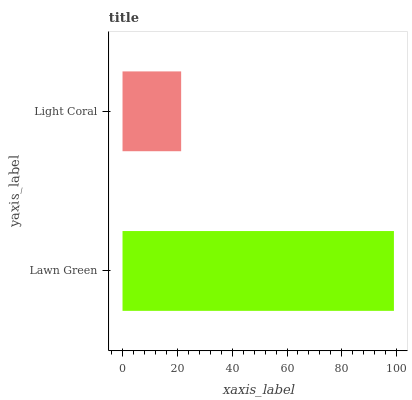Is Light Coral the minimum?
Answer yes or no. Yes. Is Lawn Green the maximum?
Answer yes or no. Yes. Is Light Coral the maximum?
Answer yes or no. No. Is Lawn Green greater than Light Coral?
Answer yes or no. Yes. Is Light Coral less than Lawn Green?
Answer yes or no. Yes. Is Light Coral greater than Lawn Green?
Answer yes or no. No. Is Lawn Green less than Light Coral?
Answer yes or no. No. Is Lawn Green the high median?
Answer yes or no. Yes. Is Light Coral the low median?
Answer yes or no. Yes. Is Light Coral the high median?
Answer yes or no. No. Is Lawn Green the low median?
Answer yes or no. No. 